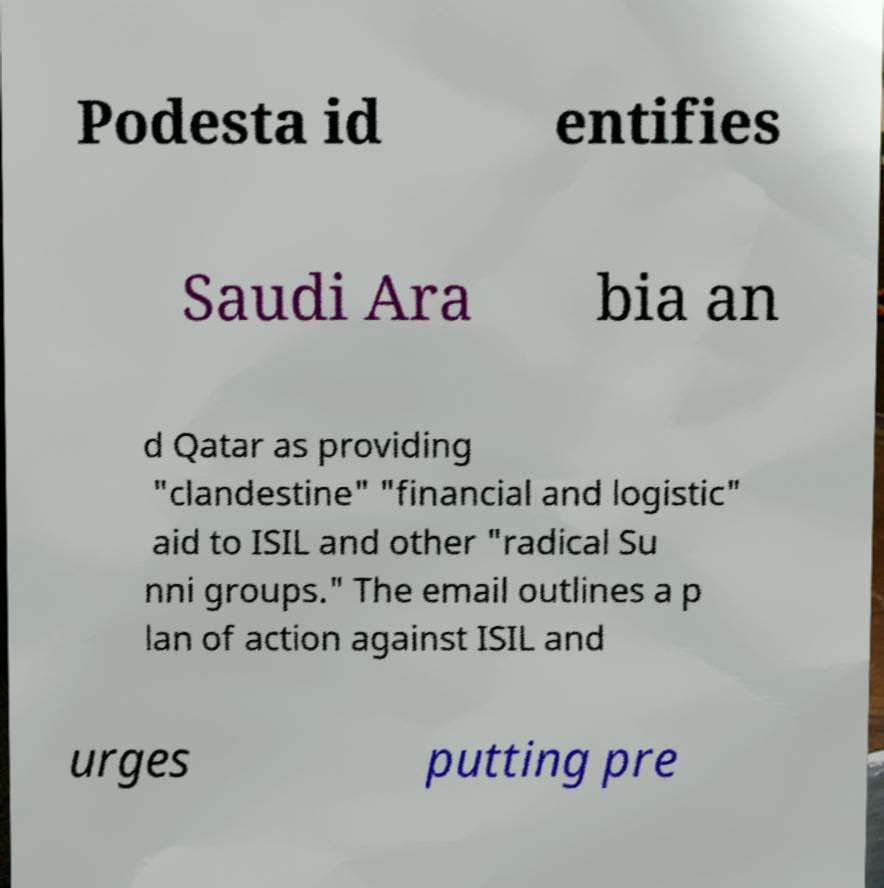What messages or text are displayed in this image? I need them in a readable, typed format. Podesta id entifies Saudi Ara bia an d Qatar as providing "clandestine" "financial and logistic" aid to ISIL and other "radical Su nni groups." The email outlines a p lan of action against ISIL and urges putting pre 